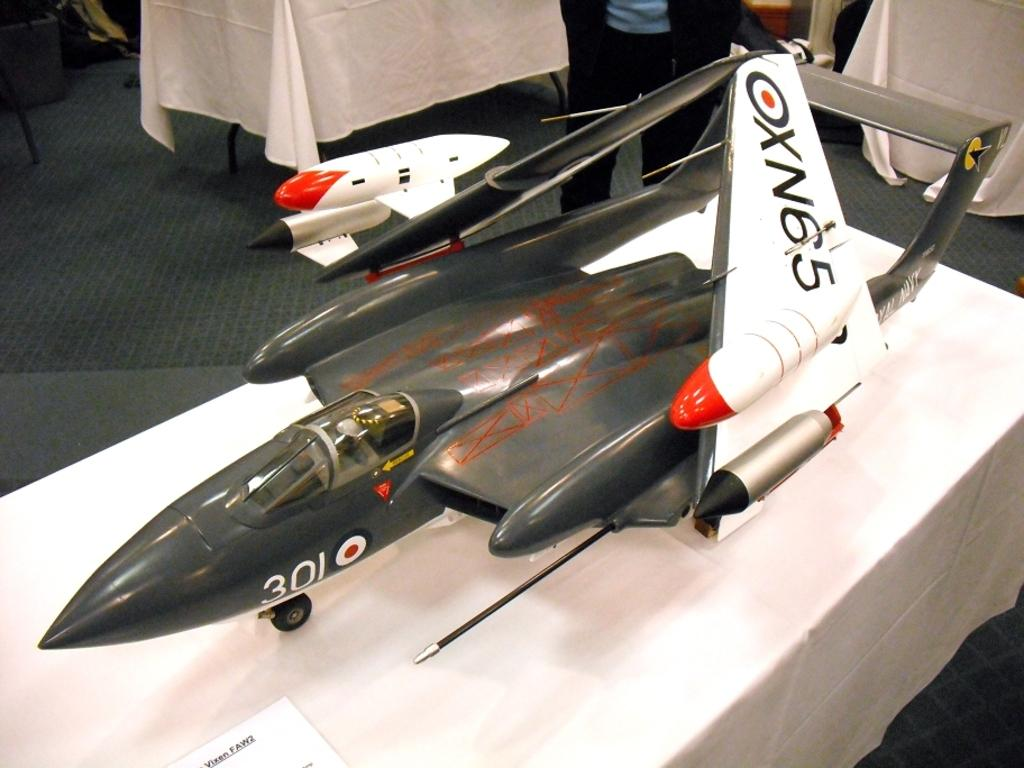<image>
Relay a brief, clear account of the picture shown. a plane with the number 301 on the side of it 